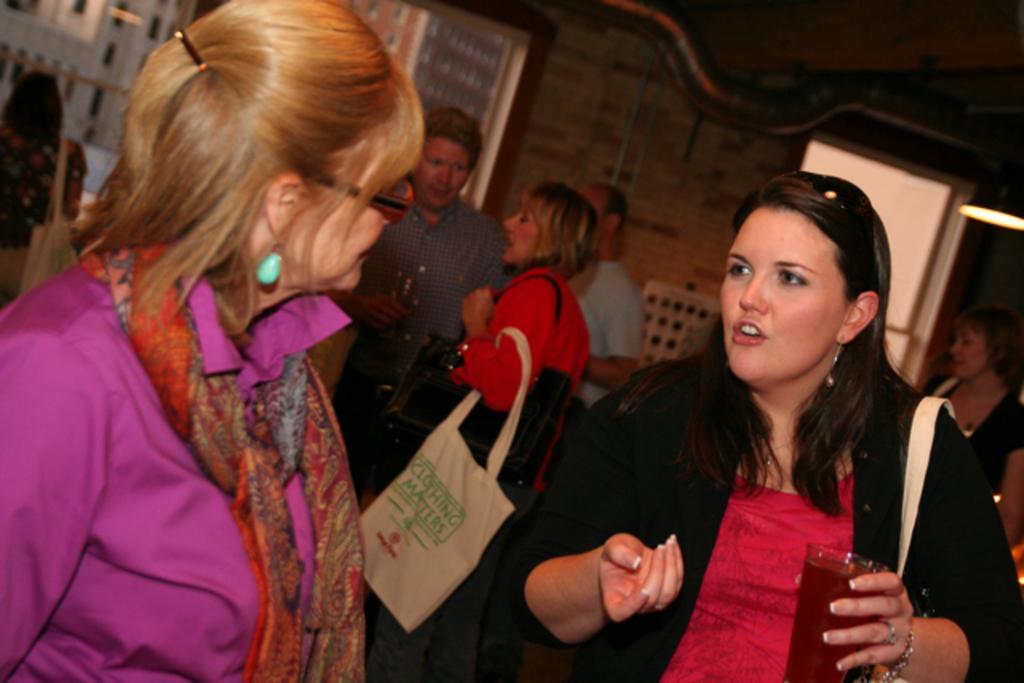How would you summarize this image in a sentence or two? In this image I can see the group of people with different color dresses. I can see few people with the bags and few people are holding the glasses. In the background I can see the wall and there is a light at the top. 